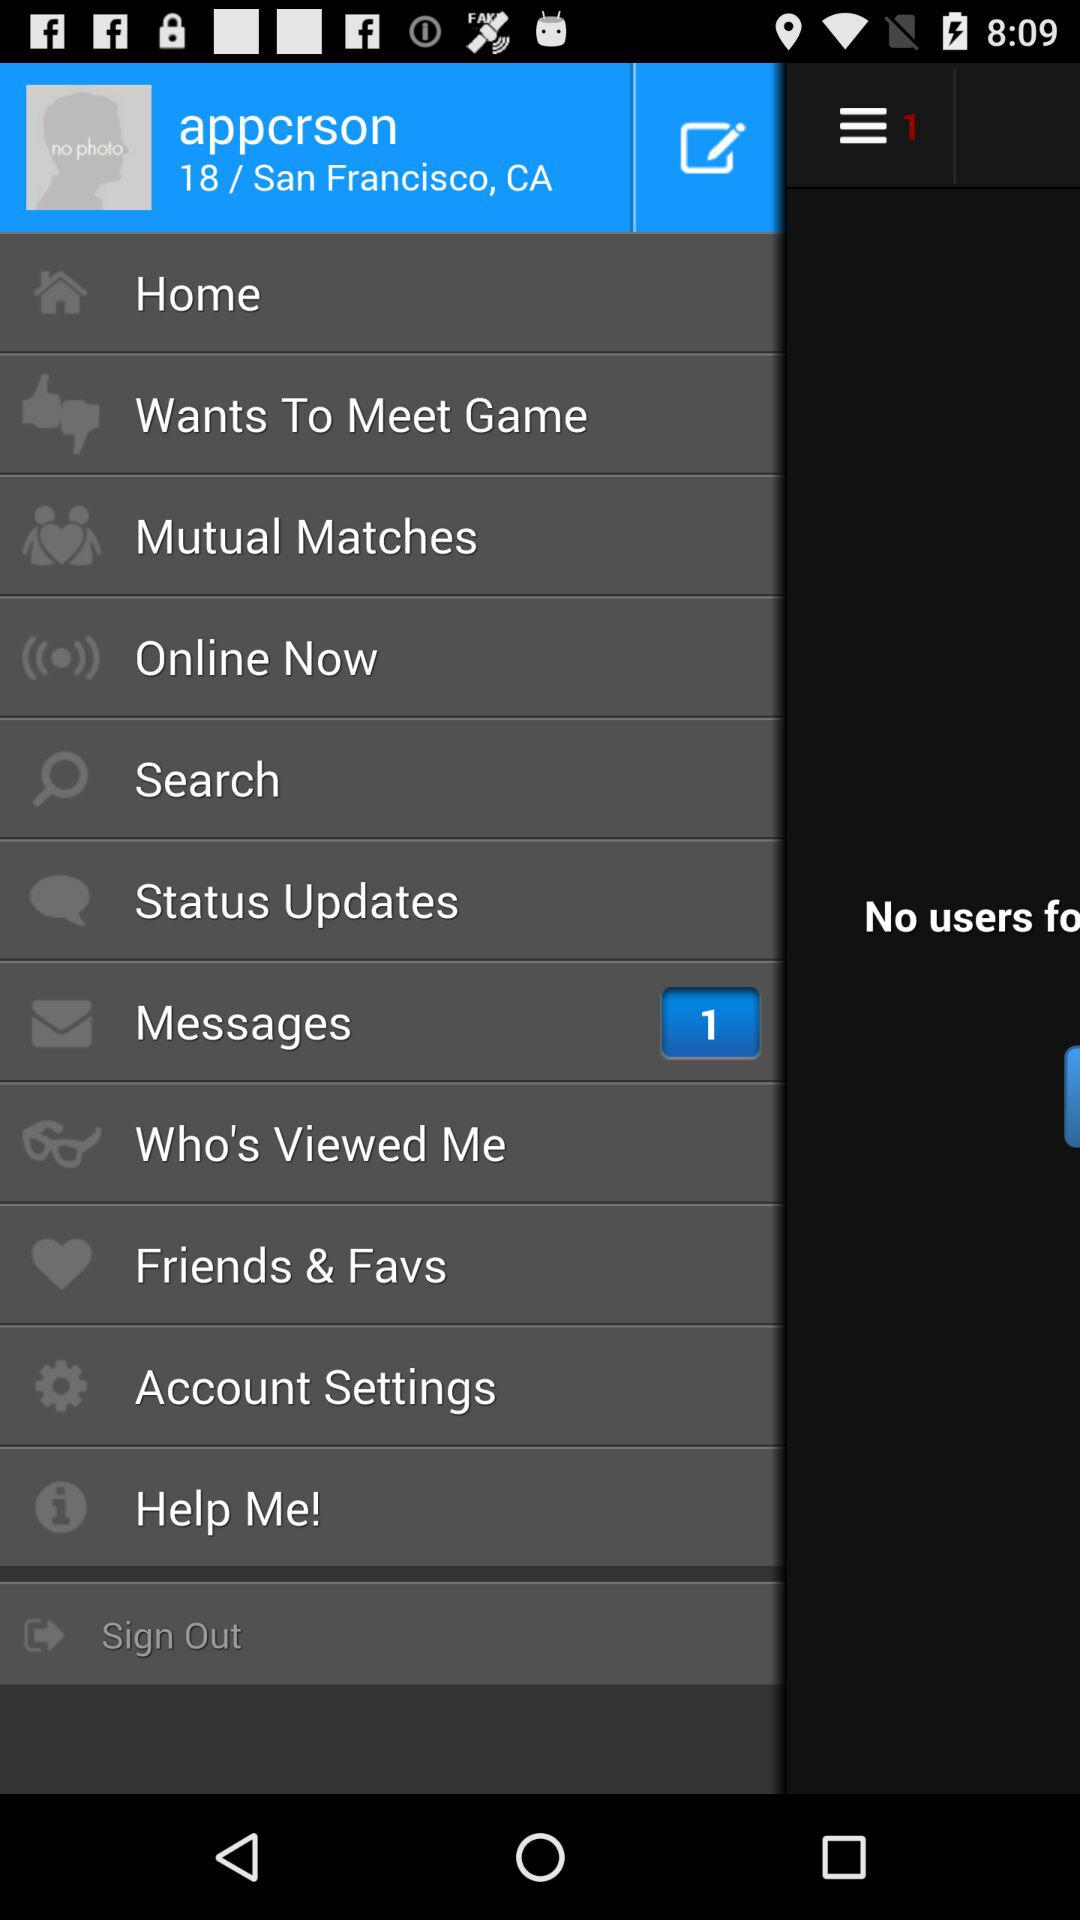What is the username? The username is "appcrson". 